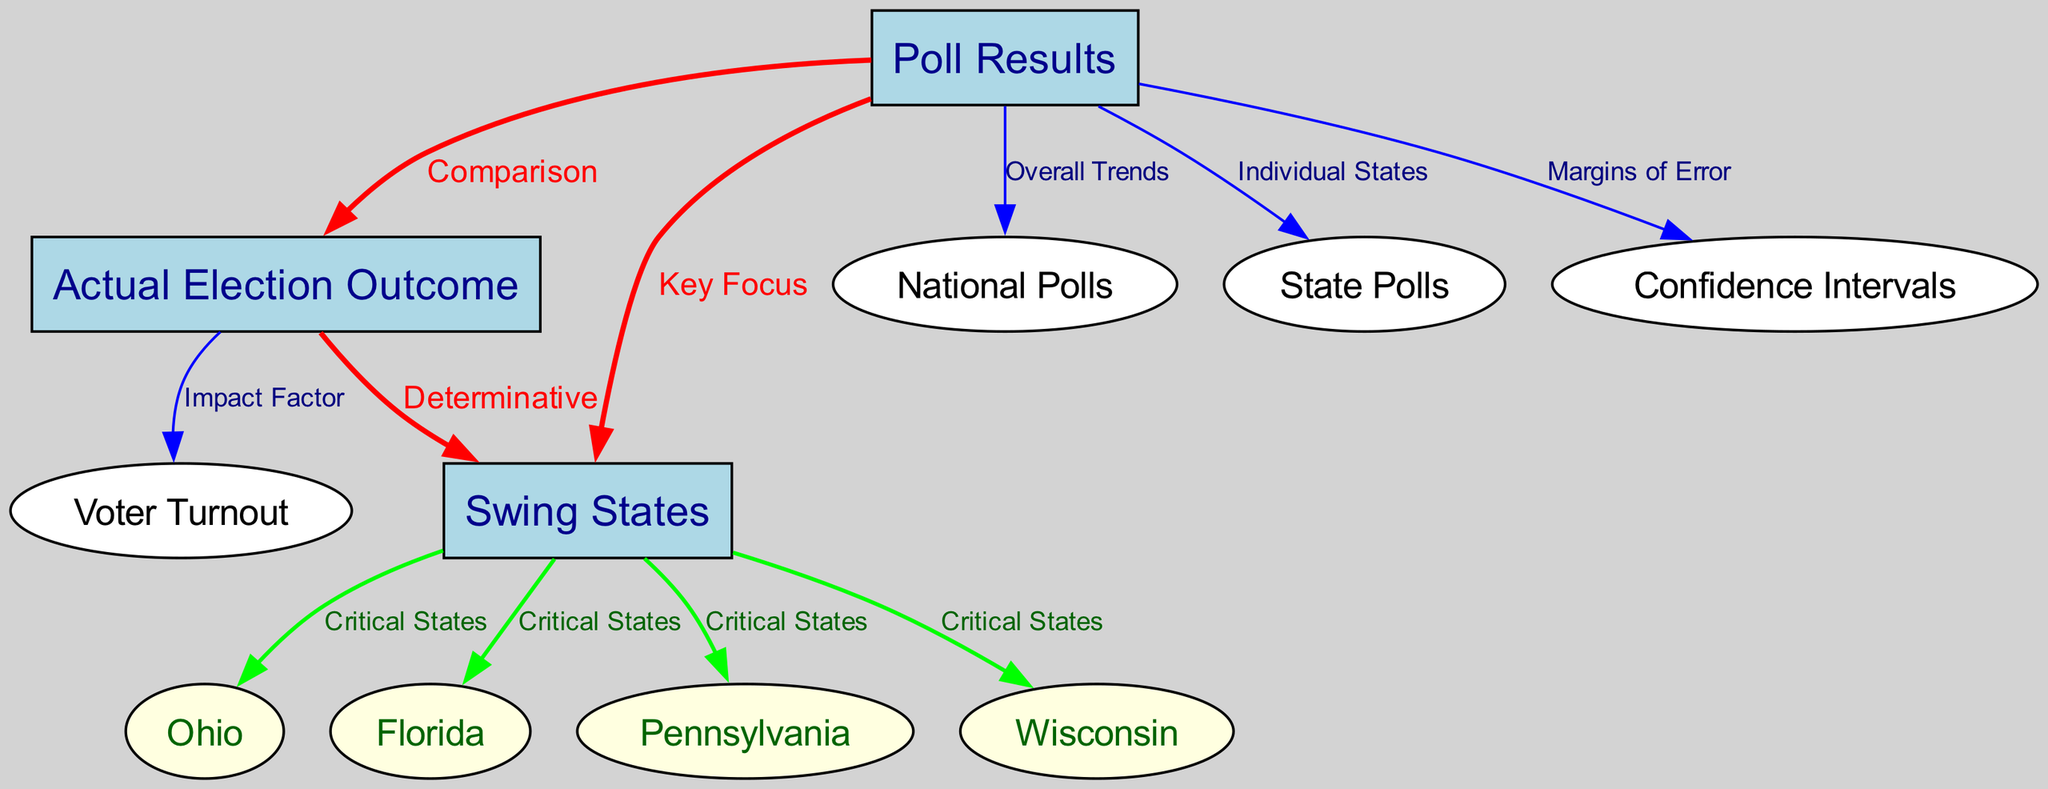What are the three main categories shown in the diagram? The diagram includes three main categories represented as nodes: "Poll Results," "Actual Election Outcome," and "Swing States." These are the key focus areas in the context of elections.
Answer: Poll Results, Actual Election Outcome, Swing States How many states are identified as swing states in the diagram? The diagram shows four swing states: Ohio, Florida, Pennsylvania, and Wisconsin, which are critical in determining the election outcome.
Answer: Four What is the relationship between "Poll Results" and "Actual Election Outcome"? The diagram indicates a direct connection where the "Poll Results" are compared with the "Actual Election Outcome," highlighting the analysis of how well polls predicted or reflected the real election results.
Answer: Comparison What do the confidence intervals relate to in this context? The confidence intervals are connected to "Poll Results," indicating the margins of error that come into play when analyzing the accuracy of the polls.
Answer: Margins of Error Which swing state is represented as a critical state in the diagram? The diagram lists four states as critical swing states: Ohio, Florida, Pennsylvania, and Wisconsin, emphasizing their significance in the election results.
Answer: Ohio, Florida, Pennsylvania, Wisconsin How does "Voter Turnout" factor into the "Actual Election Outcome"? The diagram points out that "Voter Turnout" is an impact factor related to the "Actual Election Outcome," suggesting that how many people vote plays a crucial role in determining the final results.
Answer: Impact Factor What type of connection exists between "Swing States" and "Poll Results"? The connection indicates that the "Poll Results" are a key focus area when considering "Swing States," highlighting the importance of polls in predicting outcomes in these pivotal areas.
Answer: Key Focus What color is used for the edges labeled as "Critical States"? The diagram uses green for edges labeled as "Critical States," signifying their importance and highlighting them differently from other connections.
Answer: Green What do the "National Polls" analyze in relation to "Poll Results"? "National Polls" are analyzed for overall trends in relation to "Poll Results," providing a broader perspective on how different areas are behaving in terms of polling.
Answer: Overall Trends 